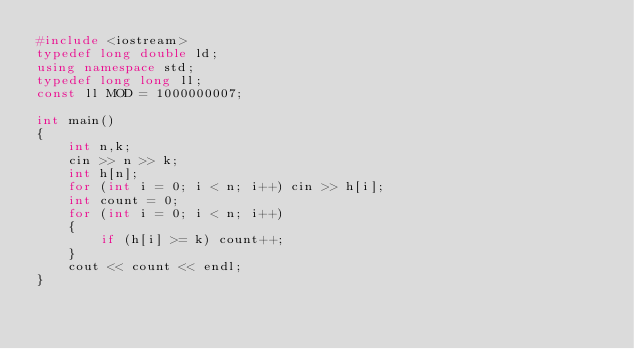Convert code to text. <code><loc_0><loc_0><loc_500><loc_500><_C++_>#include <iostream>
typedef long double ld;
using namespace std;
typedef long long ll;
const ll MOD = 1000000007;

int main()
{
    int n,k;
    cin >> n >> k;
    int h[n];
    for (int i = 0; i < n; i++) cin >> h[i];
    int count = 0;
    for (int i = 0; i < n; i++)
    {
        if (h[i] >= k) count++;
    }
    cout << count << endl;
}</code> 